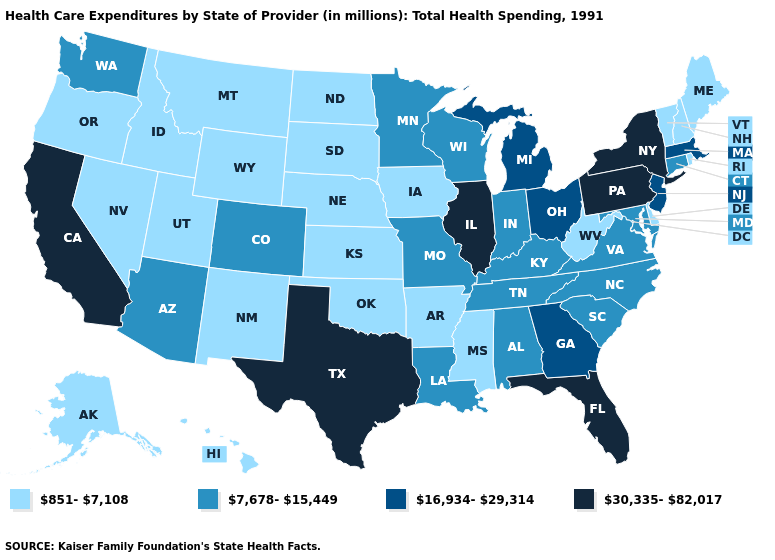What is the value of Tennessee?
Write a very short answer. 7,678-15,449. Which states have the lowest value in the USA?
Answer briefly. Alaska, Arkansas, Delaware, Hawaii, Idaho, Iowa, Kansas, Maine, Mississippi, Montana, Nebraska, Nevada, New Hampshire, New Mexico, North Dakota, Oklahoma, Oregon, Rhode Island, South Dakota, Utah, Vermont, West Virginia, Wyoming. What is the highest value in the USA?
Short answer required. 30,335-82,017. Does New Jersey have the lowest value in the USA?
Keep it brief. No. Name the states that have a value in the range 30,335-82,017?
Write a very short answer. California, Florida, Illinois, New York, Pennsylvania, Texas. What is the value of Wisconsin?
Answer briefly. 7,678-15,449. What is the value of Maryland?
Answer briefly. 7,678-15,449. What is the value of Washington?
Give a very brief answer. 7,678-15,449. Does Michigan have the highest value in the USA?
Short answer required. No. Name the states that have a value in the range 851-7,108?
Short answer required. Alaska, Arkansas, Delaware, Hawaii, Idaho, Iowa, Kansas, Maine, Mississippi, Montana, Nebraska, Nevada, New Hampshire, New Mexico, North Dakota, Oklahoma, Oregon, Rhode Island, South Dakota, Utah, Vermont, West Virginia, Wyoming. What is the value of Vermont?
Answer briefly. 851-7,108. Name the states that have a value in the range 7,678-15,449?
Be succinct. Alabama, Arizona, Colorado, Connecticut, Indiana, Kentucky, Louisiana, Maryland, Minnesota, Missouri, North Carolina, South Carolina, Tennessee, Virginia, Washington, Wisconsin. Does Mississippi have the same value as North Carolina?
Short answer required. No. Among the states that border Wyoming , which have the highest value?
Concise answer only. Colorado. Does Montana have the same value as Kentucky?
Quick response, please. No. 